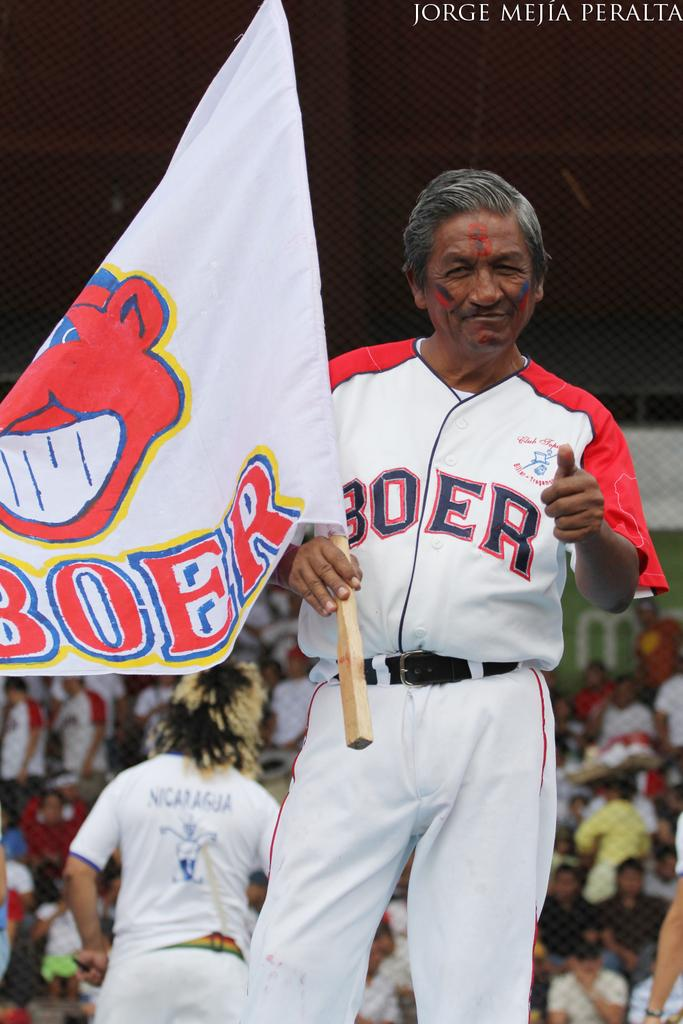<image>
Offer a succinct explanation of the picture presented. A man wearing a BOER shirt carrying a BOER flag. 